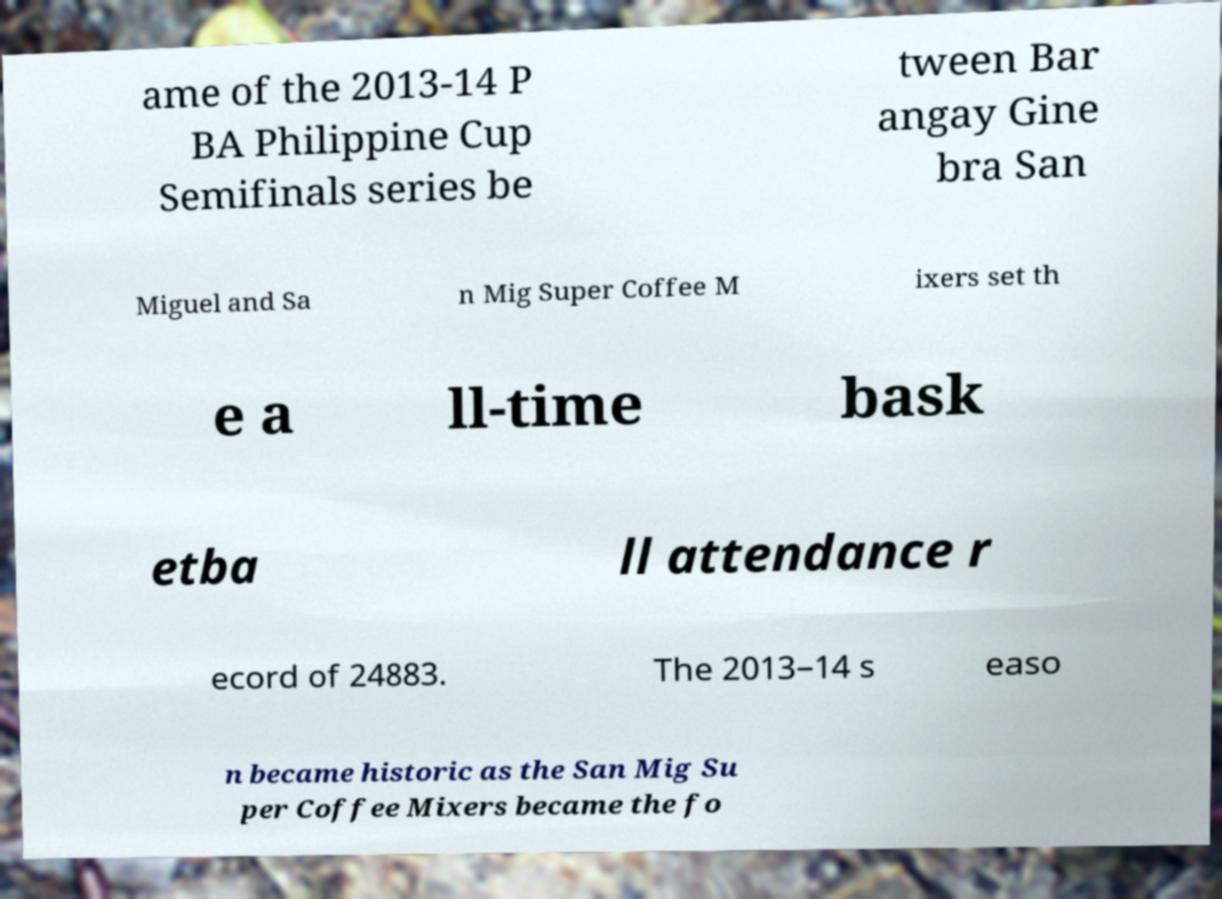Can you read and provide the text displayed in the image?This photo seems to have some interesting text. Can you extract and type it out for me? ame of the 2013-14 P BA Philippine Cup Semifinals series be tween Bar angay Gine bra San Miguel and Sa n Mig Super Coffee M ixers set th e a ll-time bask etba ll attendance r ecord of 24883. The 2013–14 s easo n became historic as the San Mig Su per Coffee Mixers became the fo 